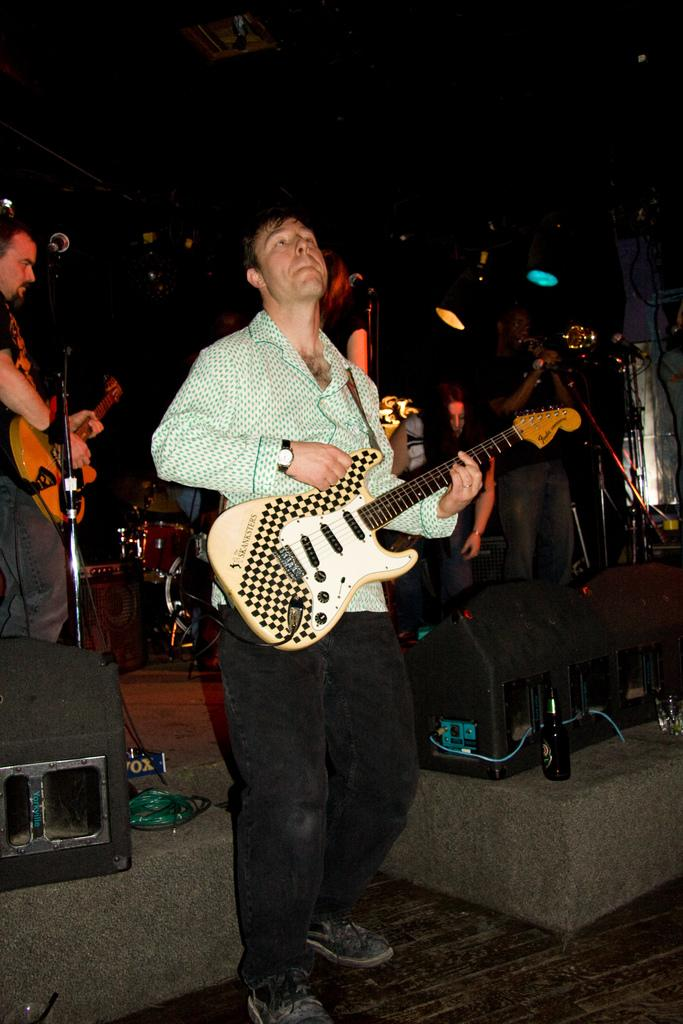What is the lighting condition in the image? The background of the image is dark. What are the people in the image doing? At least one person is playing a guitar, and at least one person is singing. What can be seen behind the people? There is a platform in the image. What is the primary object in the foreground of the image? The primary object in the foreground of the image is a mic. What type of beef is being served on the platform in the image? There is no beef present in the image; it features people performing on a platform with a mic. 